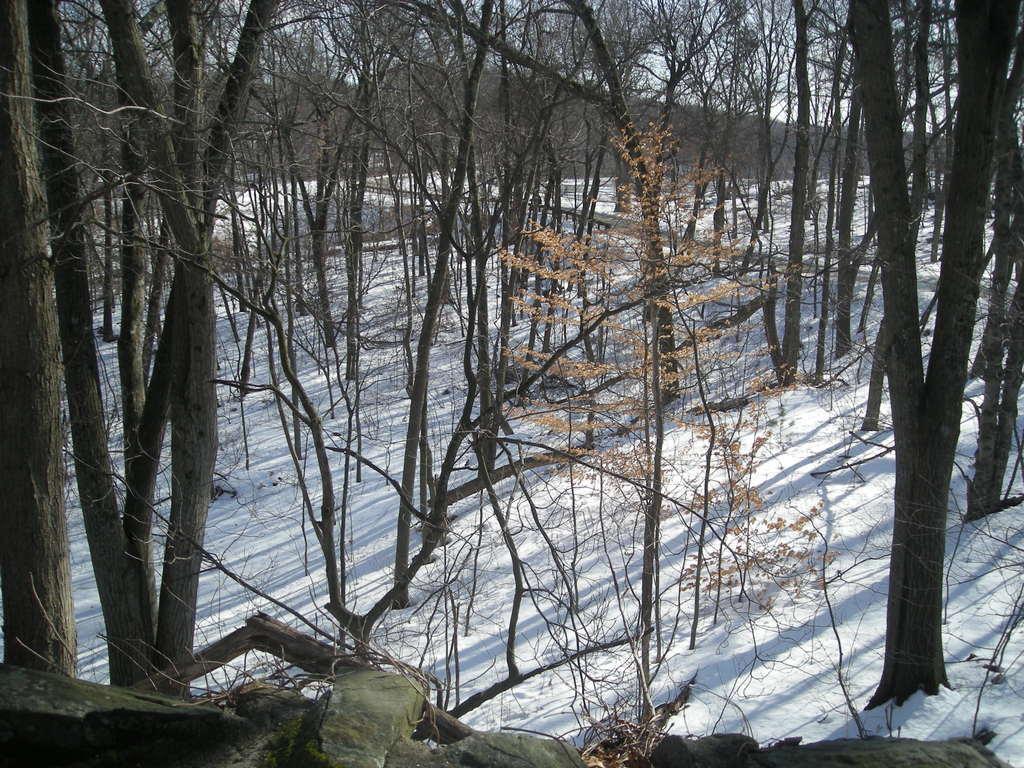In one or two sentences, can you explain what this image depicts? In this image there are group of trees, at the bottom there is snow and in the background there are mountains and sky. 